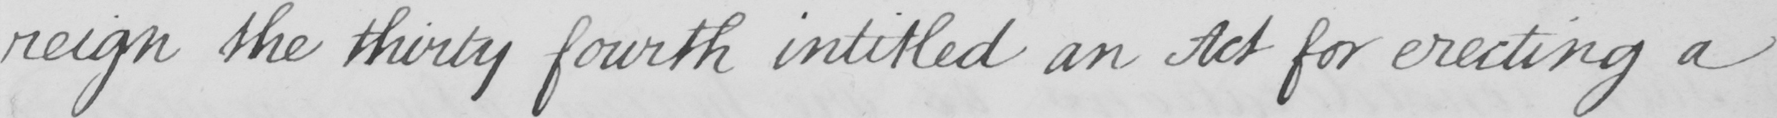Can you read and transcribe this handwriting? reign the thirty fourth intitled an Act for erecting a 